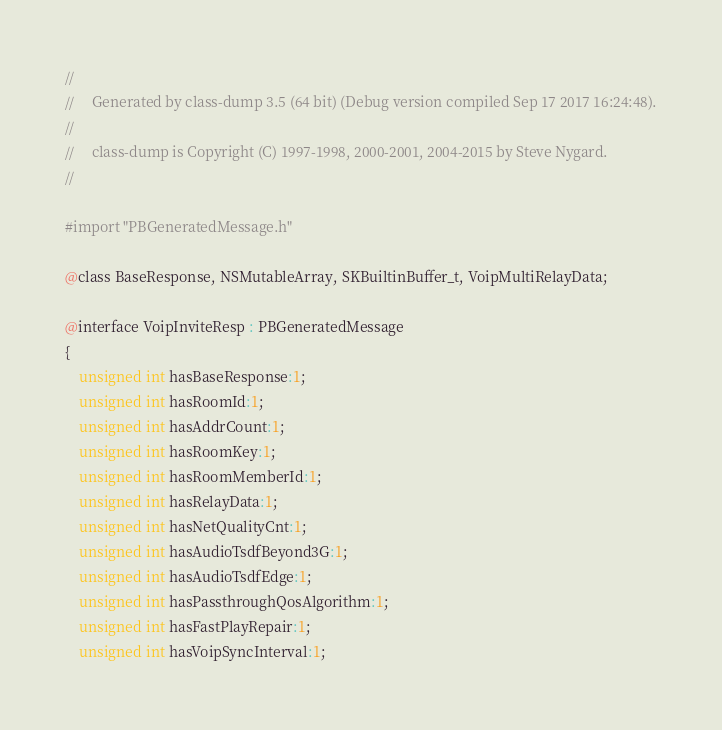Convert code to text. <code><loc_0><loc_0><loc_500><loc_500><_C_>//
//     Generated by class-dump 3.5 (64 bit) (Debug version compiled Sep 17 2017 16:24:48).
//
//     class-dump is Copyright (C) 1997-1998, 2000-2001, 2004-2015 by Steve Nygard.
//

#import "PBGeneratedMessage.h"

@class BaseResponse, NSMutableArray, SKBuiltinBuffer_t, VoipMultiRelayData;

@interface VoipInviteResp : PBGeneratedMessage
{
    unsigned int hasBaseResponse:1;
    unsigned int hasRoomId:1;
    unsigned int hasAddrCount:1;
    unsigned int hasRoomKey:1;
    unsigned int hasRoomMemberId:1;
    unsigned int hasRelayData:1;
    unsigned int hasNetQualityCnt:1;
    unsigned int hasAudioTsdfBeyond3G:1;
    unsigned int hasAudioTsdfEdge:1;
    unsigned int hasPassthroughQosAlgorithm:1;
    unsigned int hasFastPlayRepair:1;
    unsigned int hasVoipSyncInterval:1;</code> 